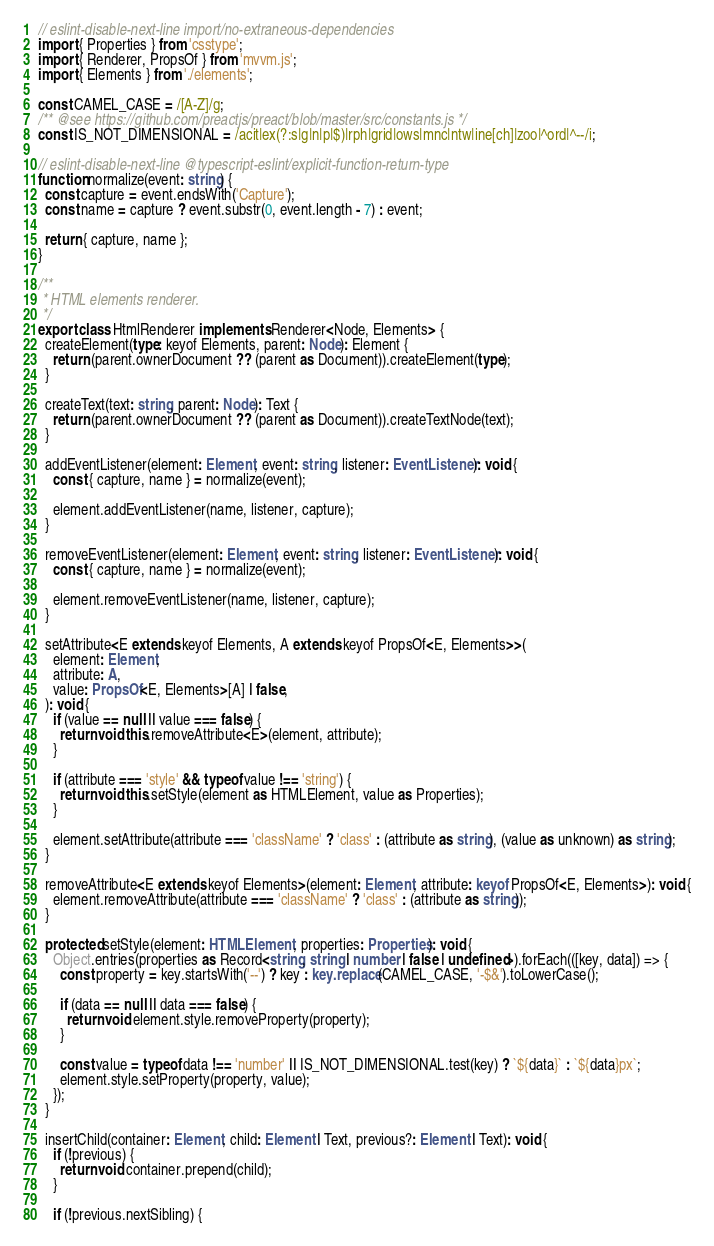<code> <loc_0><loc_0><loc_500><loc_500><_TypeScript_>// eslint-disable-next-line import/no-extraneous-dependencies
import { Properties } from 'csstype';
import { Renderer, PropsOf } from 'mvvm.js';
import { Elements } from './elements';

const CAMEL_CASE = /[A-Z]/g;
/** @see https://github.com/preactjs/preact/blob/master/src/constants.js */
const IS_NOT_DIMENSIONAL = /acit|ex(?:s|g|n|p|$)|rph|grid|ows|mnc|ntw|ine[ch]|zoo|^ord|^--/i;

// eslint-disable-next-line @typescript-eslint/explicit-function-return-type
function normalize(event: string) {
  const capture = event.endsWith('Capture');
  const name = capture ? event.substr(0, event.length - 7) : event;

  return { capture, name };
}

/**
 * HTML elements renderer.
 */
export class HtmlRenderer implements Renderer<Node, Elements> {
  createElement(type: keyof Elements, parent: Node): Element {
    return (parent.ownerDocument ?? (parent as Document)).createElement(type);
  }

  createText(text: string, parent: Node): Text {
    return (parent.ownerDocument ?? (parent as Document)).createTextNode(text);
  }

  addEventListener(element: Element, event: string, listener: EventListener): void {
    const { capture, name } = normalize(event);

    element.addEventListener(name, listener, capture);
  }

  removeEventListener(element: Element, event: string, listener: EventListener): void {
    const { capture, name } = normalize(event);

    element.removeEventListener(name, listener, capture);
  }

  setAttribute<E extends keyof Elements, A extends keyof PropsOf<E, Elements>>(
    element: Element,
    attribute: A,
    value: PropsOf<E, Elements>[A] | false,
  ): void {
    if (value == null || value === false) {
      return void this.removeAttribute<E>(element, attribute);
    }

    if (attribute === 'style' && typeof value !== 'string') {
      return void this.setStyle(element as HTMLElement, value as Properties);
    }

    element.setAttribute(attribute === 'className' ? 'class' : (attribute as string), (value as unknown) as string);
  }

  removeAttribute<E extends keyof Elements>(element: Element, attribute: keyof PropsOf<E, Elements>): void {
    element.removeAttribute(attribute === 'className' ? 'class' : (attribute as string));
  }

  protected setStyle(element: HTMLElement, properties: Properties): void {
    Object.entries(properties as Record<string, string | number | false | undefined>).forEach(([key, data]) => {
      const property = key.startsWith('--') ? key : key.replace(CAMEL_CASE, '-$&').toLowerCase();

      if (data == null || data === false) {
        return void element.style.removeProperty(property);
      }

      const value = typeof data !== 'number' || IS_NOT_DIMENSIONAL.test(key) ? `${data}` : `${data}px`;
      element.style.setProperty(property, value);
    });
  }

  insertChild(container: Element, child: Element | Text, previous?: Element | Text): void {
    if (!previous) {
      return void container.prepend(child);
    }

    if (!previous.nextSibling) {</code> 